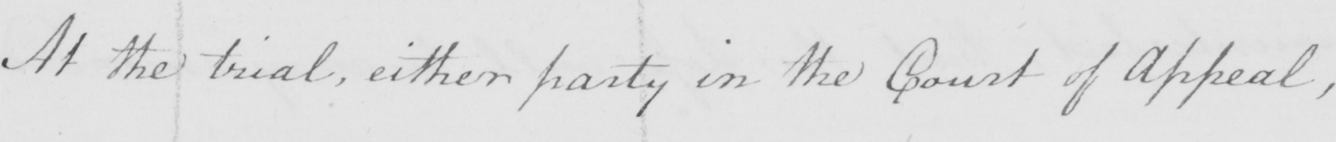What does this handwritten line say? At the trial , either party in the Court of Appeal , 